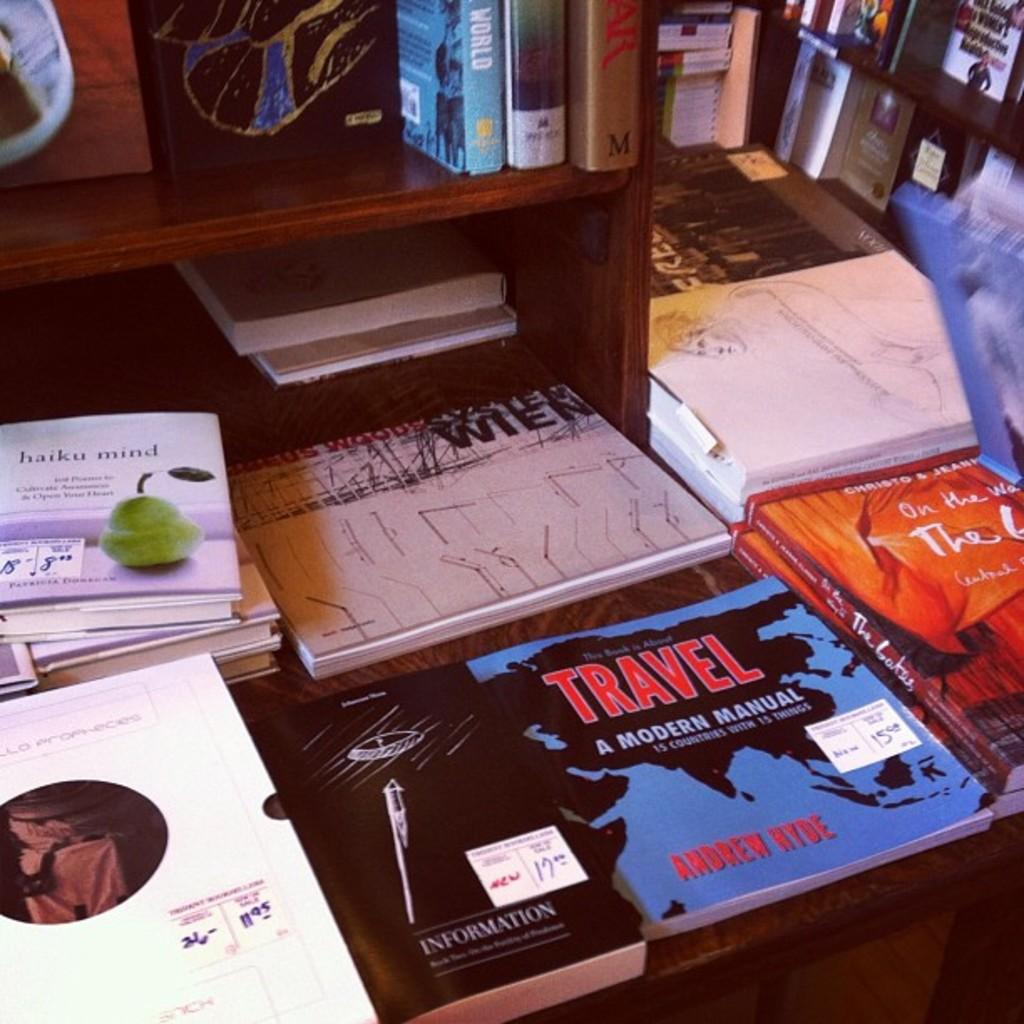<image>
Share a concise interpretation of the image provided. the word travel that is on a book 